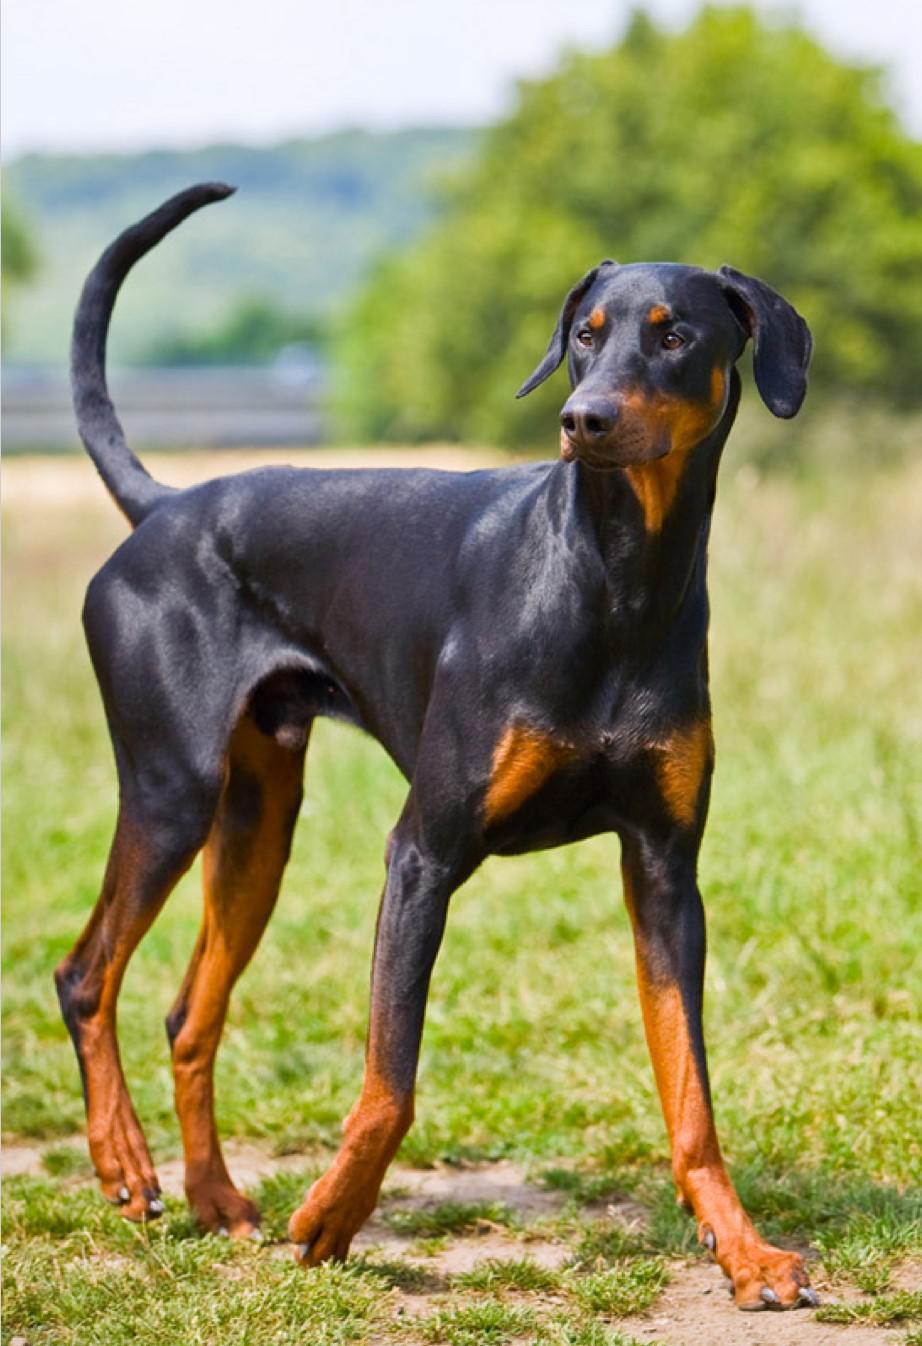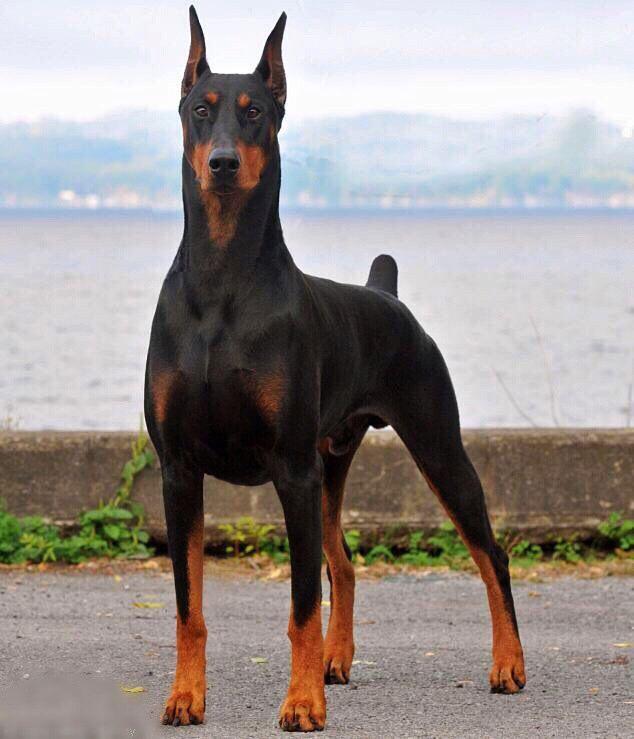The first image is the image on the left, the second image is the image on the right. Assess this claim about the two images: "One dog's tail is docked; the other dog's tail is normal.". Correct or not? Answer yes or no. Yes. The first image is the image on the left, the second image is the image on the right. For the images displayed, is the sentence "The left image shows a floppy-eared doberman standing with its undocked tail curled upward, and the right image shows a doberman with pointy erect ears and a docked tail who is standing up." factually correct? Answer yes or no. Yes. 